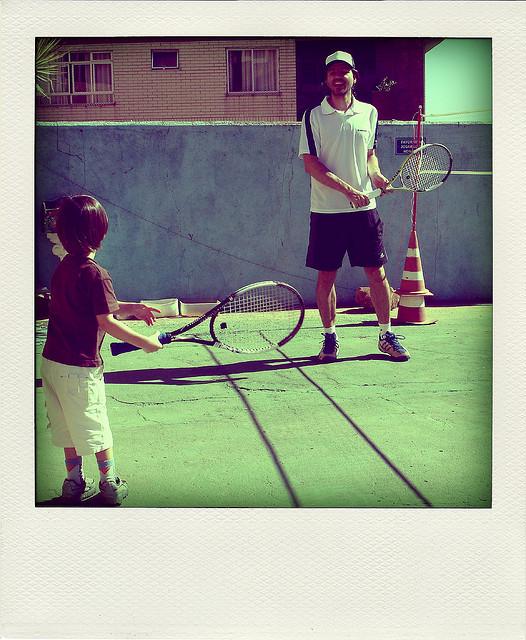Why is the man smiling?
Quick response, please. Happy. Which player is more likely to win in a competitive match?
Be succinct. Adult. Which player has the ball?
Be succinct. Neither. Is this a color photo?
Quick response, please. Yes. What game are these people playing?
Concise answer only. Tennis. What is he standing on?
Concise answer only. Tennis court. 